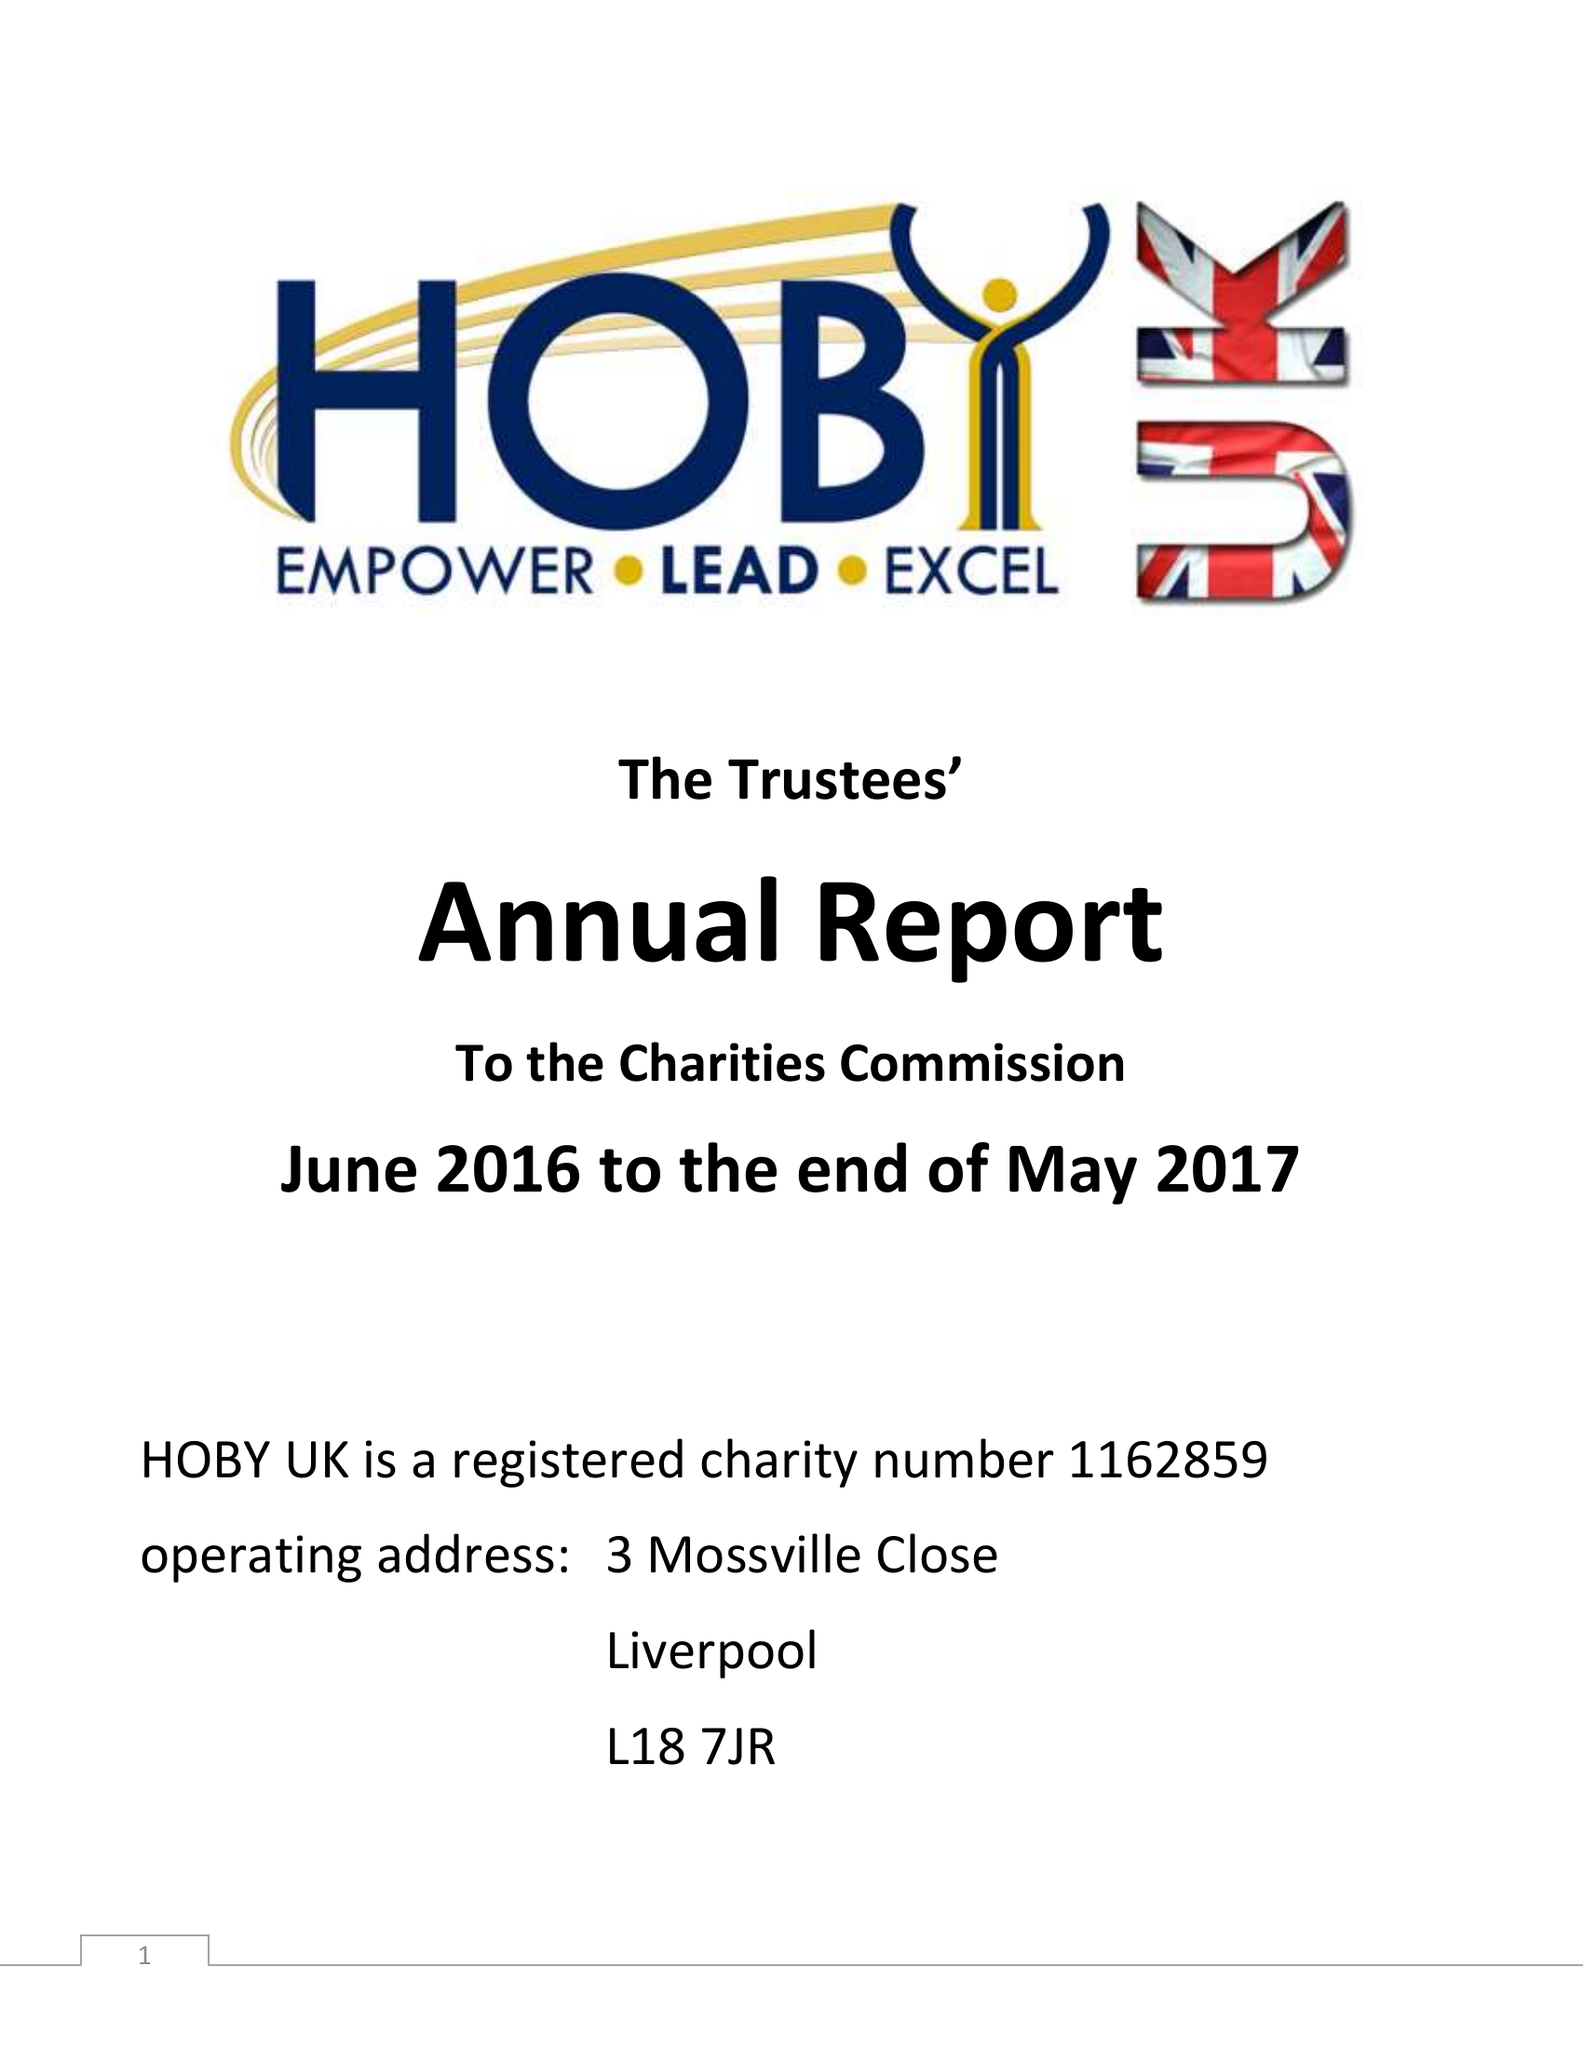What is the value for the report_date?
Answer the question using a single word or phrase. 2017-05-31 